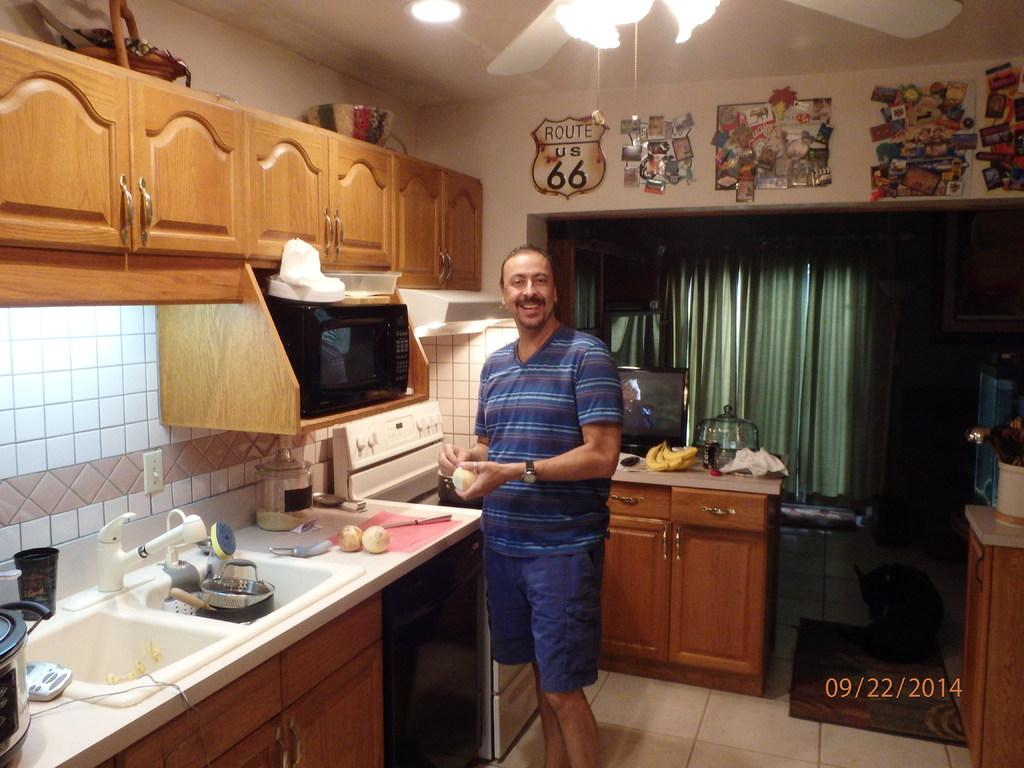<image>
Create a compact narrative representing the image presented. A man stands in a kitchen in front of a Route 66 sign on the wall. 